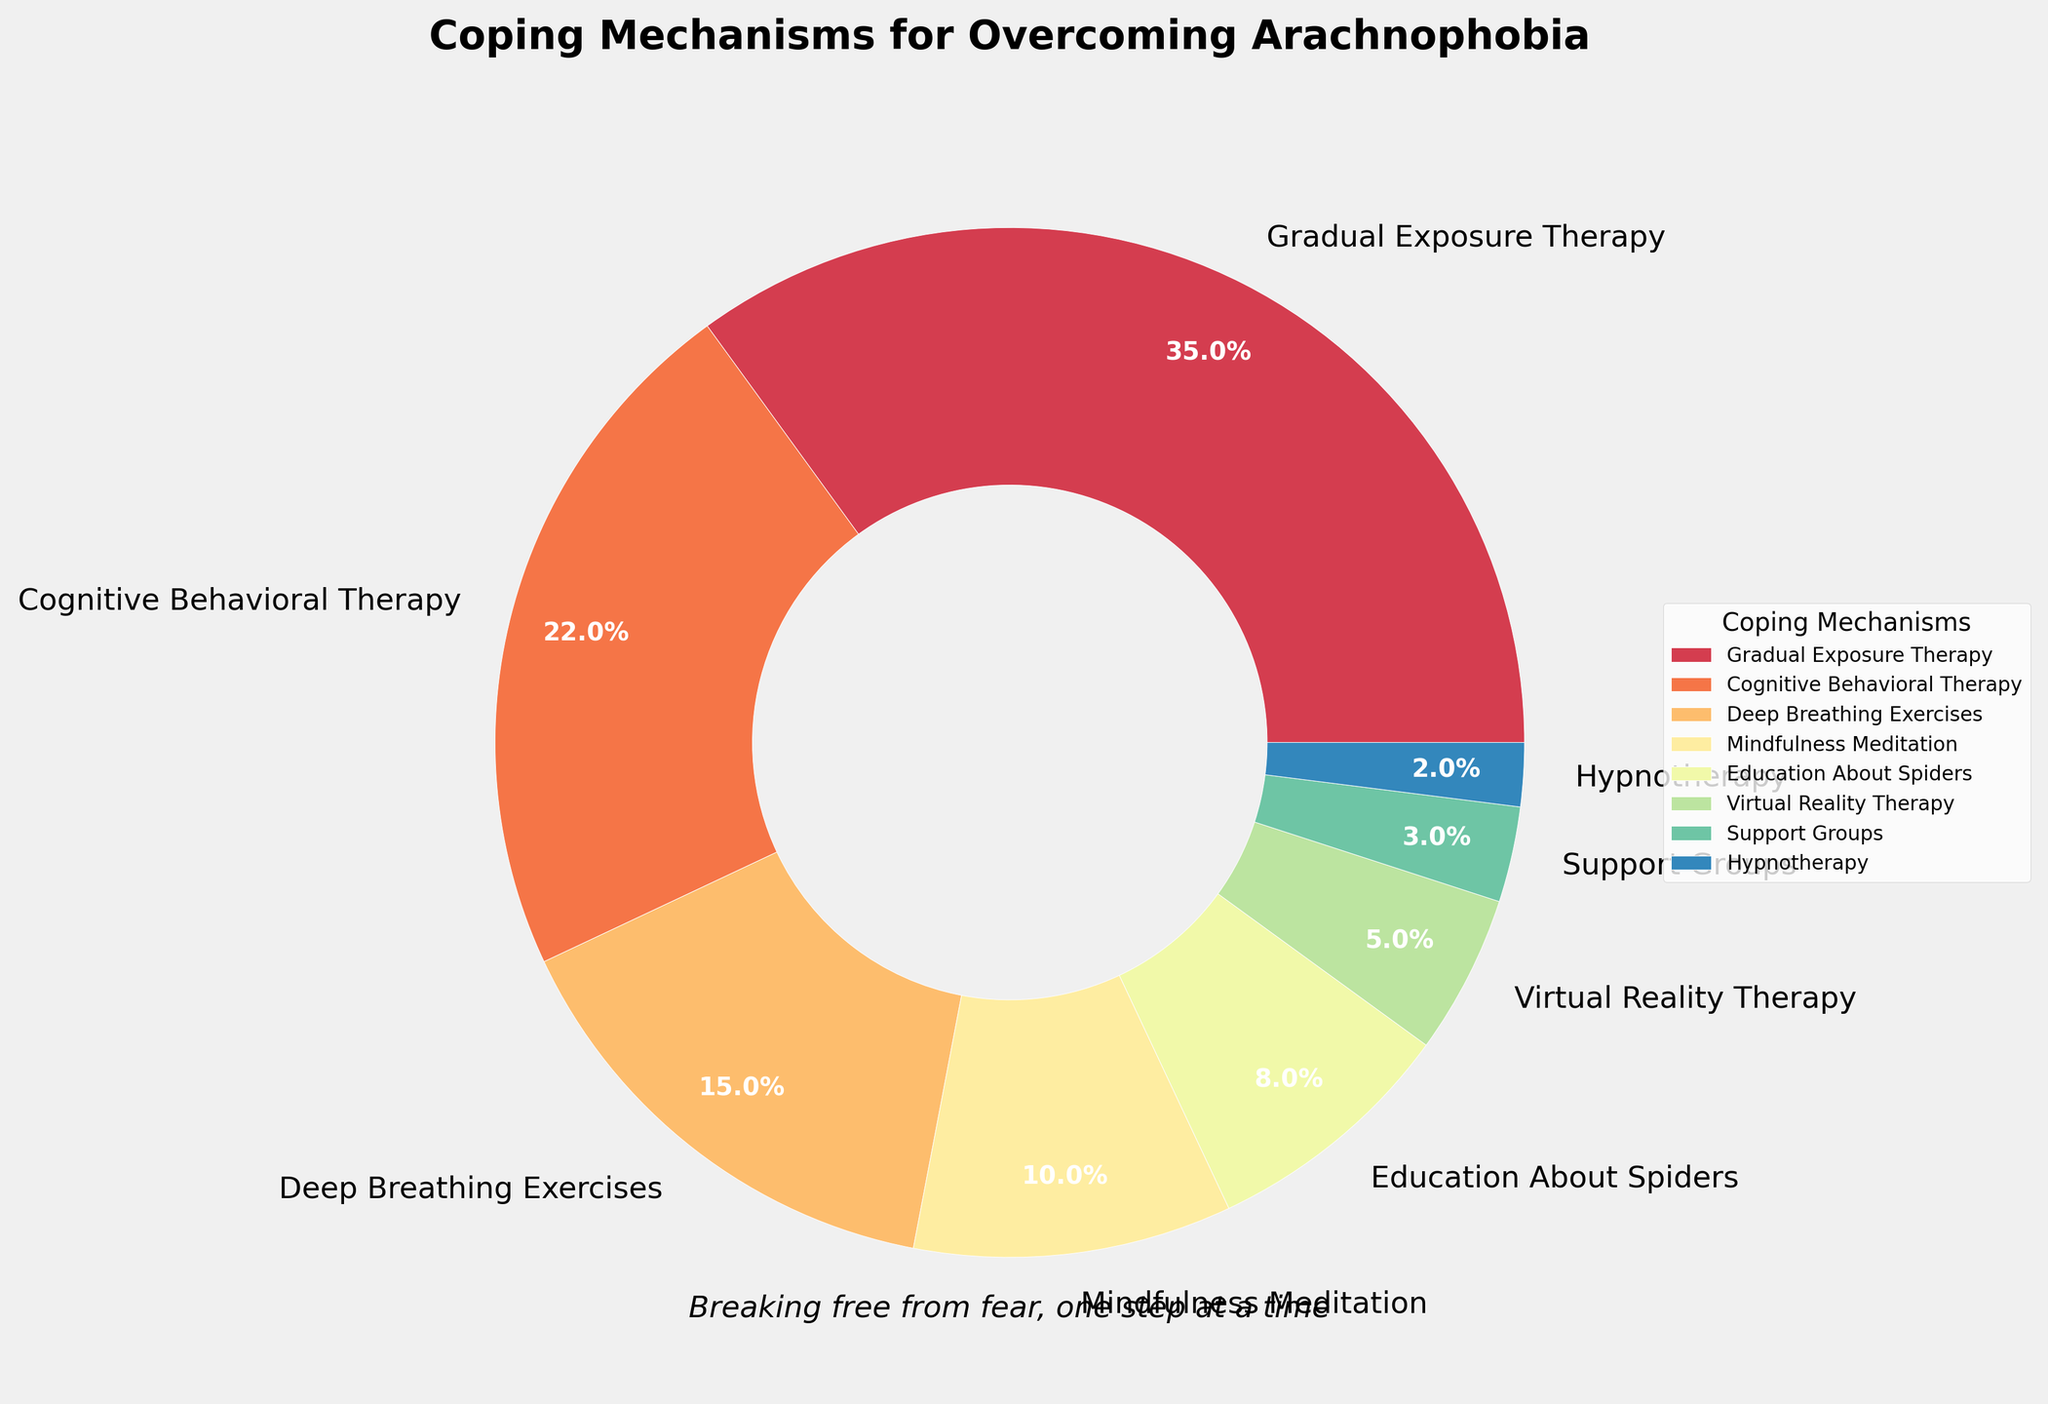Which coping mechanism is used the most by individuals overcoming arachnophobia? By looking at the pie chart, the largest wedge represents Gradual Exposure Therapy, indicating it has the highest percentage among the coping mechanisms.
Answer: Gradual Exposure Therapy Which coping mechanism represents less than 5% of the total? Observing the pie chart, the mechanisms with smallest wedges are Virtual Reality Therapy, Support Groups, and Hypnotherapy, with Support Groups and Hypnotherapy making up less than 5%.
Answer: Support Groups, Hypnotherapy What is the combined percentage of people using Deep Breathing Exercises and Mindfulness Meditation? The pie chart shows Deep Breathing Exercises at 15% and Mindfulness Meditation at 10%. Adding these values gives us 15% + 10% = 25%.
Answer: 25% How much larger is the percentage for Gradual Exposure Therapy compared to Cognitive Behavioral Therapy? Gradual Exposure Therapy is at 35% and Cognitive Behavioral Therapy is at 22%. Subtracting these values gives 35% - 22% = 13%.
Answer: 13% How many coping mechanisms account for at least 10% each? By examining the pie chart, we see that Gradual Exposure Therapy, Cognitive Behavioral Therapy, Deep Breathing Exercises, and Mindfulness Meditation each account for at least 10%.
Answer: 4 What is the second most common coping mechanism? The second largest wedge in the pie chart represents Cognitive Behavioral Therapy at 22%.
Answer: Cognitive Behavioral Therapy Compare the combined percentage of Virtual Reality Therapy and Support Groups to Mindfulness Meditation. Which is larger? Virtual Reality Therapy is 5% and Support Groups are 3%, so combined they add up to 8%. Mindfulness Meditation is 10%. Comparing these values, 10% is larger than 8%.
Answer: Mindfulness Meditation What is the percentage difference between Deep Breathing Exercises and Cognitive Behavioral Therapy? Deep Breathing Exercises are at 15% and Cognitive Behavioral Therapy is at 22%. The difference is 22% - 15% = 7%.
Answer: 7% What percentage of the pie chart is represented by the least common coping mechanism? The smallest wedge on the pie chart stands for Hypnotherapy, which is at 2%.
Answer: 2% 